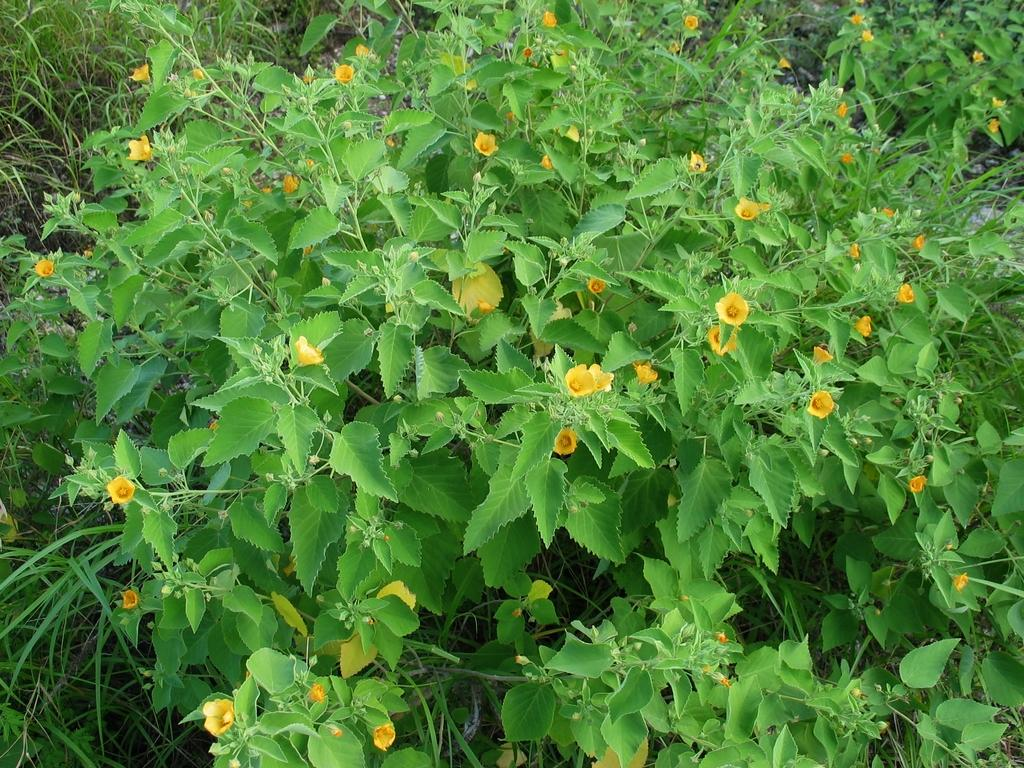What type of vegetation is present in the image? There are plants in the image. What specific features can be observed on the plants? The plants have leaves and yellow flowers. Can you describe the plants further? The plants may be grass, as they have similar characteristics. What type of beef is being served at the event in the image? There is no event or beef present in the image; it features plants with leaves and yellow flowers. 